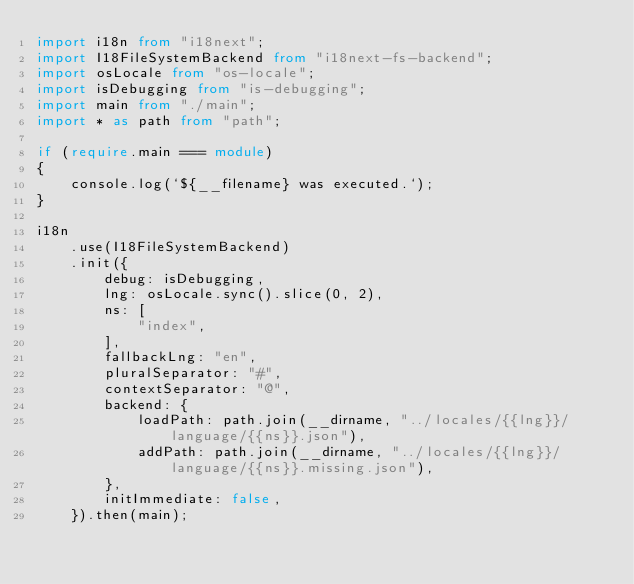Convert code to text. <code><loc_0><loc_0><loc_500><loc_500><_TypeScript_>import i18n from "i18next";
import I18FileSystemBackend from "i18next-fs-backend";
import osLocale from "os-locale";
import isDebugging from "is-debugging";
import main from "./main";
import * as path from "path";

if (require.main === module)
{
    console.log(`${__filename} was executed.`);
}

i18n
    .use(I18FileSystemBackend)
    .init({
        debug: isDebugging,
        lng: osLocale.sync().slice(0, 2),
        ns: [
            "index",
        ],
        fallbackLng: "en",
        pluralSeparator: "#",
        contextSeparator: "@",
        backend: {
            loadPath: path.join(__dirname, "../locales/{{lng}}/language/{{ns}}.json"),
            addPath: path.join(__dirname, "../locales/{{lng}}/language/{{ns}}.missing.json"),
        },
        initImmediate: false,
    }).then(main);
</code> 